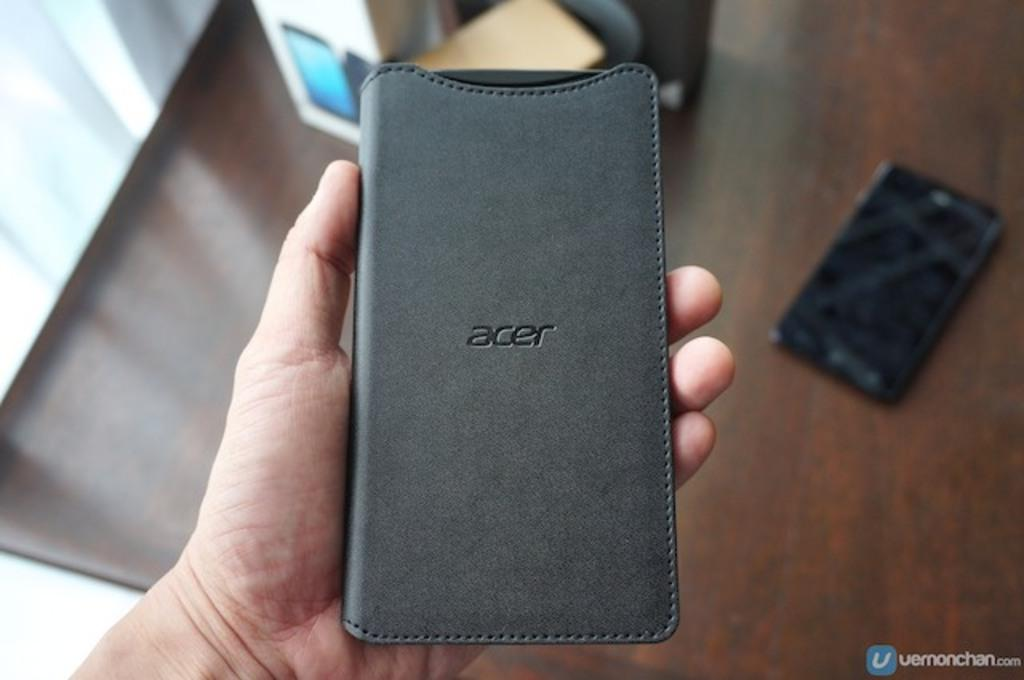<image>
Write a terse but informative summary of the picture. an ACER cell phone leather case held in a hand 